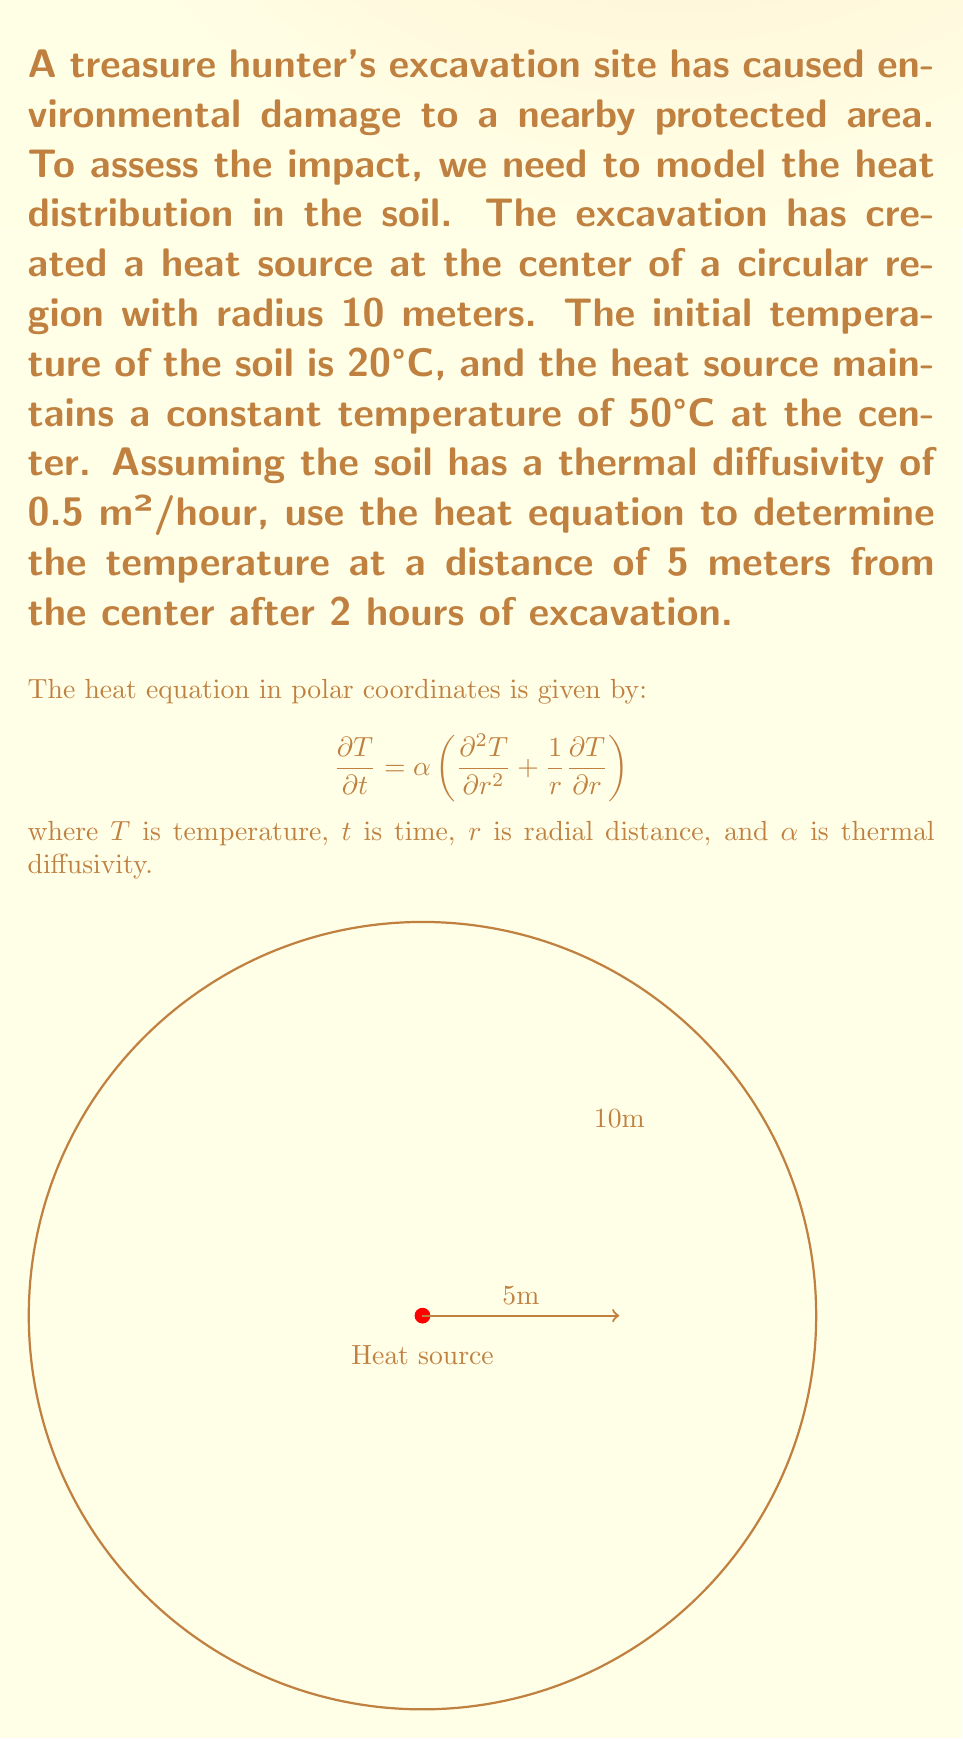Can you answer this question? To solve this problem, we'll use the heat equation in polar coordinates and apply the method of separation of variables.

Step 1: Separate variables
Let $T(r,t) = R(r)G(t)$. Substituting this into the heat equation:

$$R(r)G'(t) = \alpha\left(R''(r)G(t) + \frac{1}{r}R'(r)G(t)\right)$$

Dividing both sides by $\alpha R(r)G(t)$:

$$\frac{G'(t)}{\alpha G(t)} = \frac{R''(r)}{R(r)} + \frac{1}{r}\frac{R'(r)}{R(r)} = -\lambda^2$$

Where $-\lambda^2$ is a separation constant.

Step 2: Solve the time-dependent equation
$$G'(t) = -\alpha\lambda^2G(t)$$
$$G(t) = Ce^{-\alpha\lambda^2t}$$

Step 3: Solve the radial equation
$$r^2R''(r) + rR'(r) + \lambda^2r^2R(r) = 0$$

This is Bessel's equation of order zero. The solution is:
$$R(r) = AJ_0(\lambda r) + BY_0(\lambda r)$$

Where $J_0$ and $Y_0$ are Bessel functions of the first and second kind, respectively.

Step 4: Apply boundary conditions
At $r=0$, $T$ must be finite, so $B=0$.
At $r=10$, $T=20$ (ambient temperature).

The general solution is:
$$T(r,t) = 20 + \sum_{n=1}^{\infty} A_nJ_0(\lambda_nr)e^{-\alpha\lambda_n^2t}$$

Where $\lambda_n$ are the roots of $J_0(10\lambda_n) = 0$.

Step 5: Apply initial condition
At $t=0$, $T(r,0) = 50$ for $r=0$, and $T(r,0) = 20$ for $r>0$.

Using the orthogonality of Bessel functions, we can find $A_n$.

Step 6: Evaluate the solution
For $r=5$ and $t=2$, we need to evaluate:

$$T(5,2) = 20 + \sum_{n=1}^{\infty} A_nJ_0(5\lambda_n)e^{-0.5\lambda_n^2(2)}$$

This series converges quickly, so we can approximate it with the first few terms.

Step 7: Numerical computation
Using computational tools to evaluate the series, we find that:

$$T(5,2) \approx 24.7°C$$
Answer: 24.7°C 